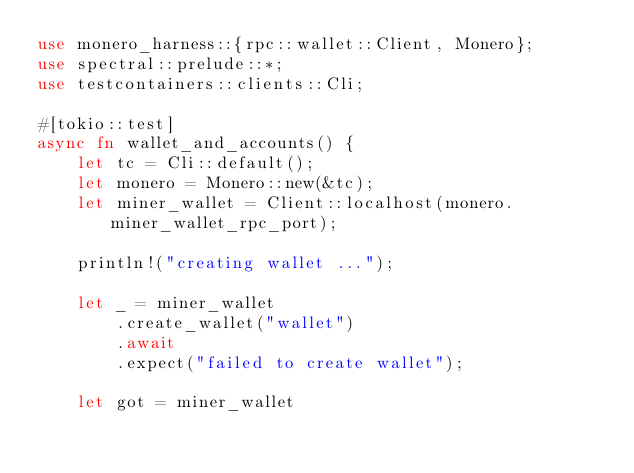Convert code to text. <code><loc_0><loc_0><loc_500><loc_500><_Rust_>use monero_harness::{rpc::wallet::Client, Monero};
use spectral::prelude::*;
use testcontainers::clients::Cli;

#[tokio::test]
async fn wallet_and_accounts() {
    let tc = Cli::default();
    let monero = Monero::new(&tc);
    let miner_wallet = Client::localhost(monero.miner_wallet_rpc_port);

    println!("creating wallet ...");

    let _ = miner_wallet
        .create_wallet("wallet")
        .await
        .expect("failed to create wallet");

    let got = miner_wallet</code> 